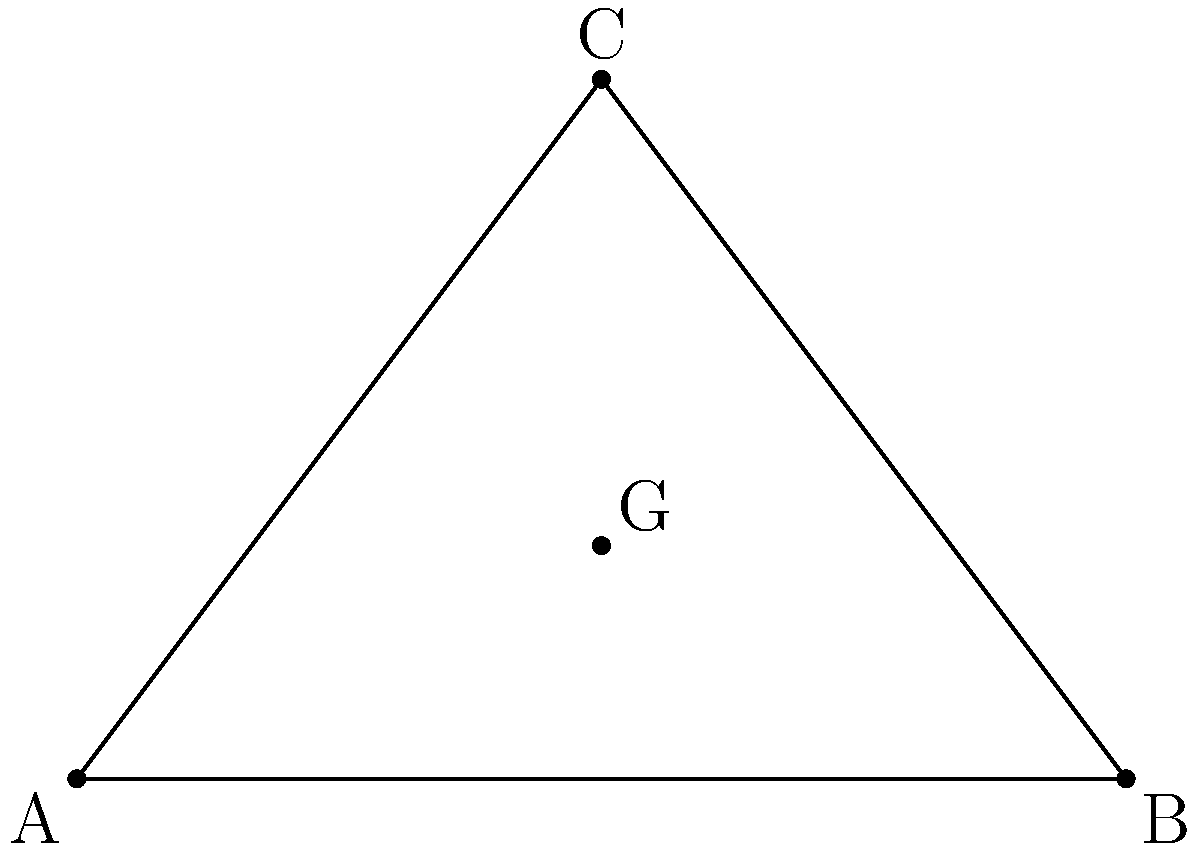As the father of the bride, you're helping design a triangular dance floor for your daughter's wedding. The stage is represented by triangle ABC, where A(0,0), B(6,0), and C(3,4) are the coordinates of the vertices in meters. Calculate the position of the centroid (G) of this triangular stage area using vector operations. This will be the ideal spot for your legendary dance moves! To find the centroid of the triangular stage, we'll follow these steps:

1) First, recall that the centroid of a triangle is located at the intersection of its medians, and it divides each median in a 2:1 ratio from the vertex.

2) We can represent the vertices as position vectors:
   $\vec{A} = \begin{pmatrix} 0 \\ 0 \end{pmatrix}$, 
   $\vec{B} = \begin{pmatrix} 6 \\ 0 \end{pmatrix}$, 
   $\vec{C} = \begin{pmatrix} 3 \\ 4 \end{pmatrix}$

3) The centroid $\vec{G}$ can be calculated using the formula:
   $$\vec{G} = \frac{1}{3}(\vec{A} + \vec{B} + \vec{C})$$

4) Let's substitute the vectors:
   $$\vec{G} = \frac{1}{3}\left(\begin{pmatrix} 0 \\ 0 \end{pmatrix} + \begin{pmatrix} 6 \\ 0 \end{pmatrix} + \begin{pmatrix} 3 \\ 4 \end{pmatrix}\right)$$

5) Add the vectors inside the parentheses:
   $$\vec{G} = \frac{1}{3}\begin{pmatrix} 9 \\ 4 \end{pmatrix}$$

6) Multiply by $\frac{1}{3}$:
   $$\vec{G} = \begin{pmatrix} 3 \\ \frac{4}{3} \end{pmatrix}$$

Thus, the centroid G is located at the point (3, 4/3) or (3, 1.33) meters from the origin.
Answer: G(3, 4/3) m 